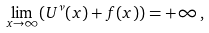<formula> <loc_0><loc_0><loc_500><loc_500>\lim _ { x \rightarrow \infty } ( U ^ { \nu } ( x ) + f ( x ) ) = + \infty \, ,</formula> 